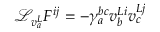Convert formula to latex. <formula><loc_0><loc_0><loc_500><loc_500>{ \mathcal { L } } _ { v _ { a } ^ { L } } F ^ { i j } = - \gamma _ { a } ^ { b c } v _ { b } ^ { L i } v _ { c } ^ { L j }</formula> 